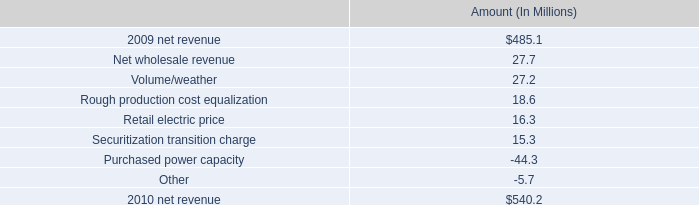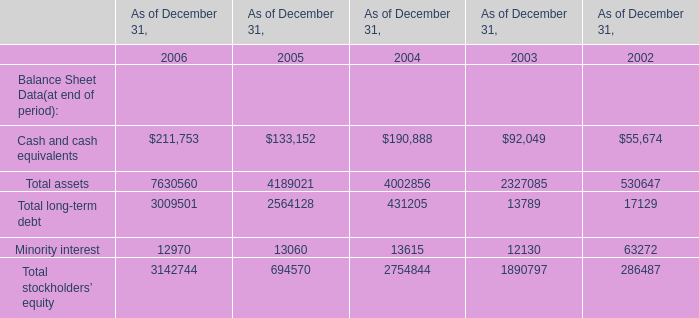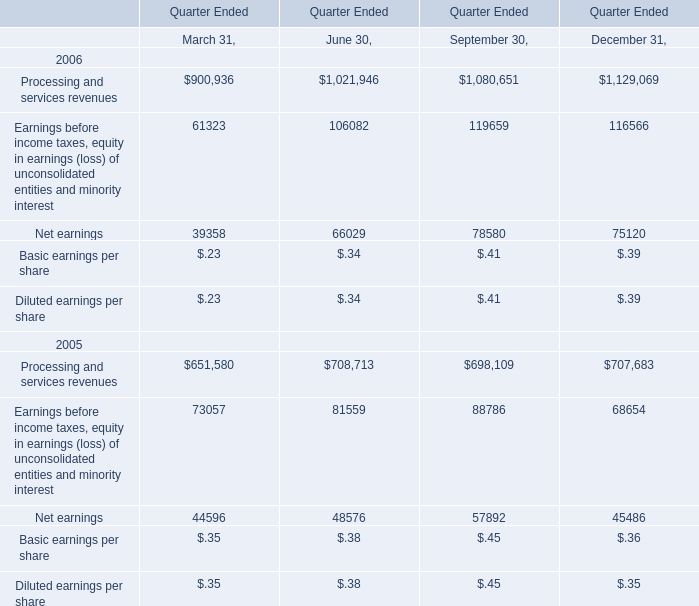In the year with the greatest proportion of Processing and services revenues, what is the proportion of Processing and services revenues to the total? 
Computations: ((((900936 + 1021946) + 1080651) + 1129069) / (((((((900936 + 1021946) + 1080651) + 1129069) + 651580) + 708713) + 698109) + 707683))
Answer: 0.59904. 